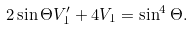<formula> <loc_0><loc_0><loc_500><loc_500>2 \sin \Theta V _ { 1 } ^ { \prime } + 4 V _ { 1 } = \sin ^ { 4 } \Theta .</formula> 